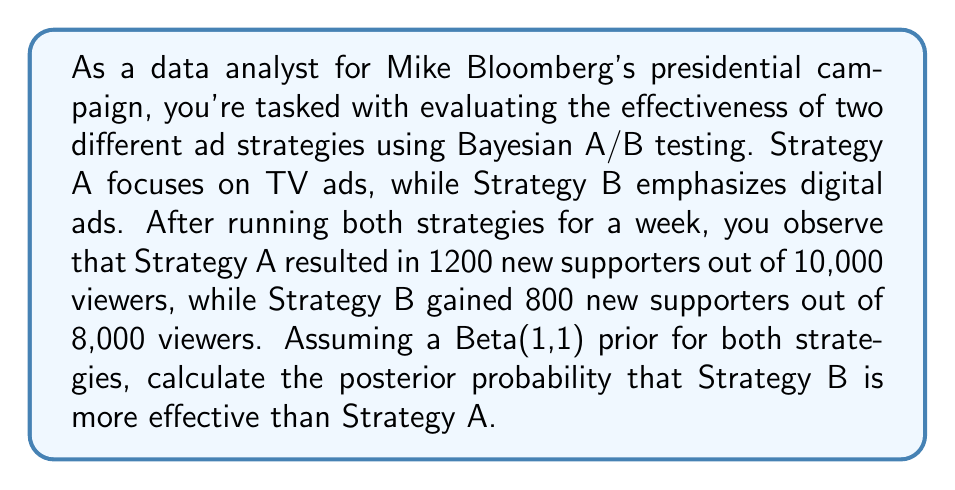Solve this math problem. Let's approach this step-by-step using Bayesian A/B testing:

1) First, we need to define our parameters:
   $\theta_A$ = conversion rate for Strategy A
   $\theta_B$ = conversion rate for Strategy B

2) We're using a Beta(1,1) prior for both strategies, which is equivalent to a uniform distribution on [0,1].

3) For Strategy A:
   - Prior: Beta(1,1)
   - Data: 1200 successes out of 10,000 trials
   - Posterior: Beta(1 + 1200, 1 + 10000 - 1200) = Beta(1201, 8801)

4) For Strategy B:
   - Prior: Beta(1,1)
   - Data: 800 successes out of 8,000 trials
   - Posterior: Beta(1 + 800, 1 + 8000 - 800) = Beta(801, 7201)

5) To calculate the probability that Strategy B is more effective, we need to compute:

   $P(\theta_B > \theta_A) = \int_0^1 \int_0^{\theta_B} f_A(\theta_A) f_B(\theta_B) d\theta_A d\theta_B$

   where $f_A$ and $f_B$ are the posterior density functions for $\theta_A$ and $\theta_B$ respectively.

6) This integral doesn't have a closed-form solution, so we need to use numerical methods. One efficient way is to use Monte Carlo simulation:

   - Generate a large number of samples (e.g., 100,000) from each posterior distribution.
   - Count the proportion of times the sample from B is greater than the sample from A.

7) Using Python with numpy for this simulation:

   ```python
   import numpy as np

   np.random.seed(0)  # for reproducibility
   samples = 100000
   theta_A = np.random.beta(1201, 8801, samples)
   theta_B = np.random.beta(801, 7201, samples)
   p_B_better = np.mean(theta_B > theta_A)
   ```

8) The result of this simulation gives us $P(\theta_B > \theta_A) \approx 0.0392$ or about 3.92%.
Answer: The posterior probability that Strategy B (digital ads) is more effective than Strategy A (TV ads) is approximately 0.0392 or 3.92%. 